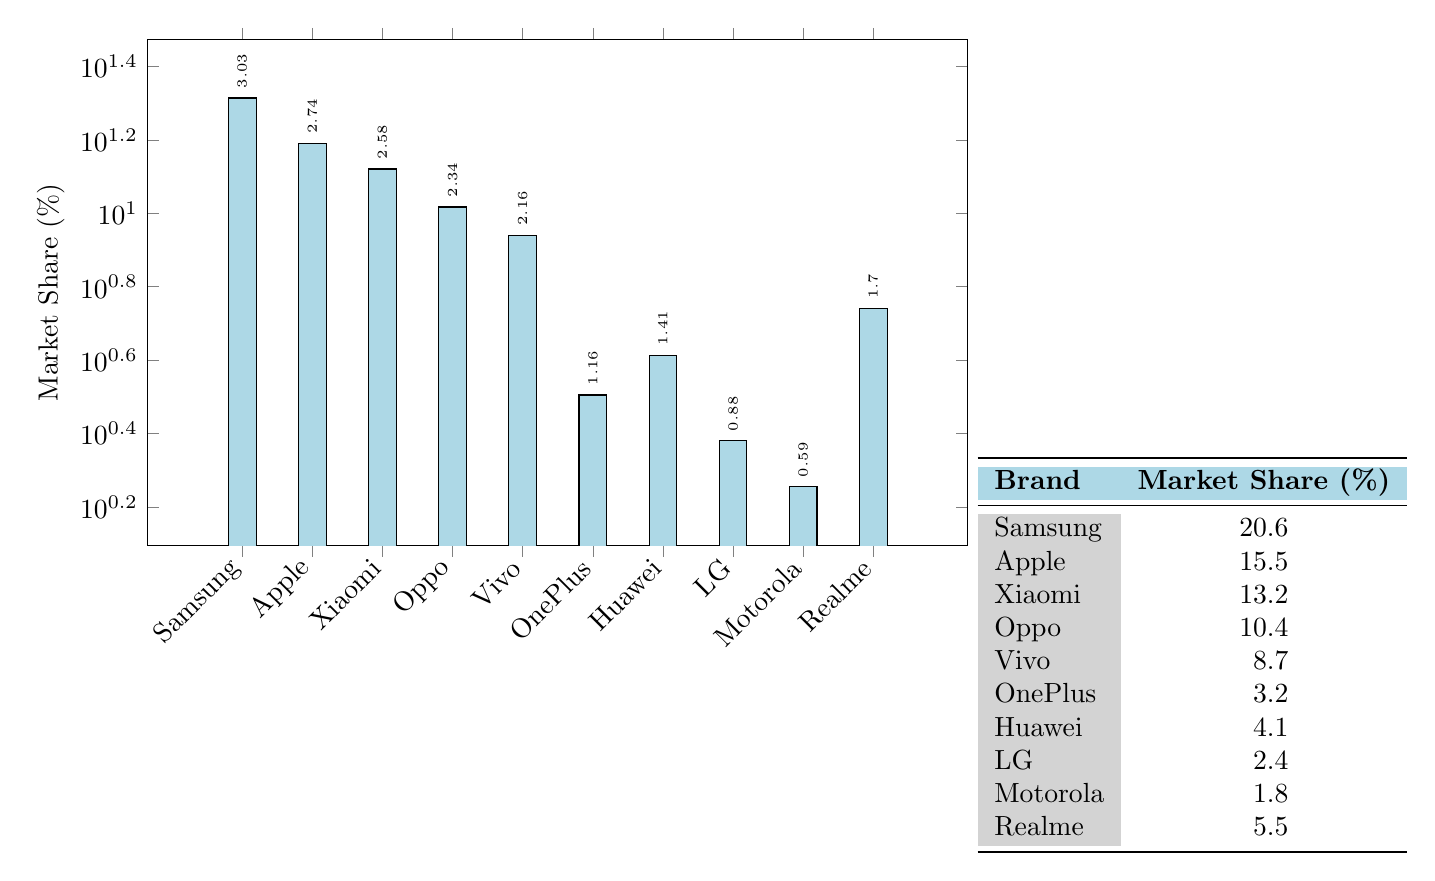What brand has the highest market share? By looking at the market share values in the table, Samsung has the highest market share listed at 20.6%.
Answer: Samsung Which brand has a market share of 5.5%? The table shows that Realme has a market share of 5.5%.
Answer: Realme What is the market share difference between Apple and OnePlus? Apple has a market share of 15.5%, and OnePlus has a market share of 3.2%. The difference is 15.5 - 3.2 = 12.3%.
Answer: 12.3% Does Vivo have a higher market share than LG? According to the table, Vivo has a market share of 8.7%, while LG has a market share of 2.4%. Since 8.7% is greater than 2.4%, the answer is yes.
Answer: Yes What is the combined market share of the top three brands? The top three brands are Samsung (20.6%), Apple (15.5%), and Xiaomi (13.2%). Adding these together gives: 20.6 + 15.5 + 13.2 = 49.3%.
Answer: 49.3% What is the median market share of all brands listed? To find the median, the market shares in ascending order are: 1.8, 2.4, 3.2, 4.1, 5.5, 8.7, 10.4, 13.2, 15.5, and 20.6. With 10 data points, the median is the average of the 5th and 6th values (5.5 and 8.7): (5.5 + 8.7) / 2 = 7.1%.
Answer: 7.1% What brand has a market share less than 3%? The table indicates that LG (2.4%) and Motorola (1.8%) both have a market share less than 3%.
Answer: Yes Which brand has a market share closest to 10%? Oppo has a market share of 10.4%, which is the closest value to 10% when comparing all brands.
Answer: Oppo 